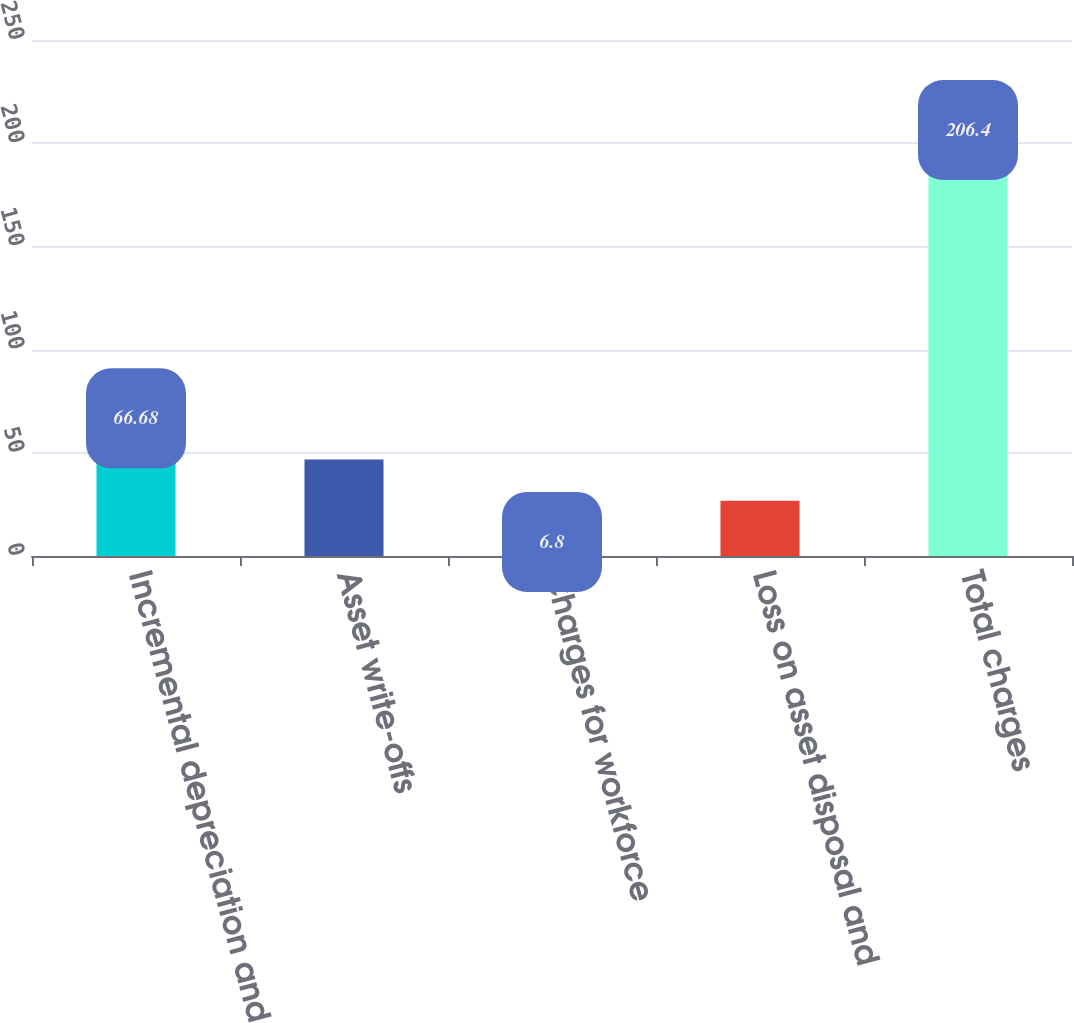Convert chart. <chart><loc_0><loc_0><loc_500><loc_500><bar_chart><fcel>Incremental depreciation and<fcel>Asset write-offs<fcel>Charges for workforce<fcel>Loss on asset disposal and<fcel>Total charges<nl><fcel>66.68<fcel>46.72<fcel>6.8<fcel>26.76<fcel>206.4<nl></chart> 